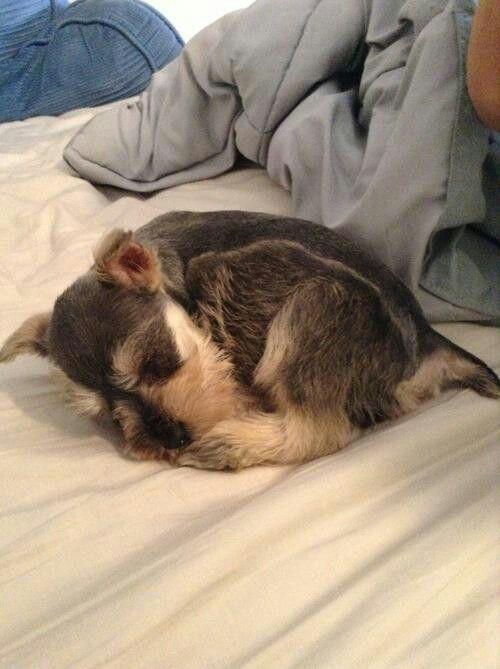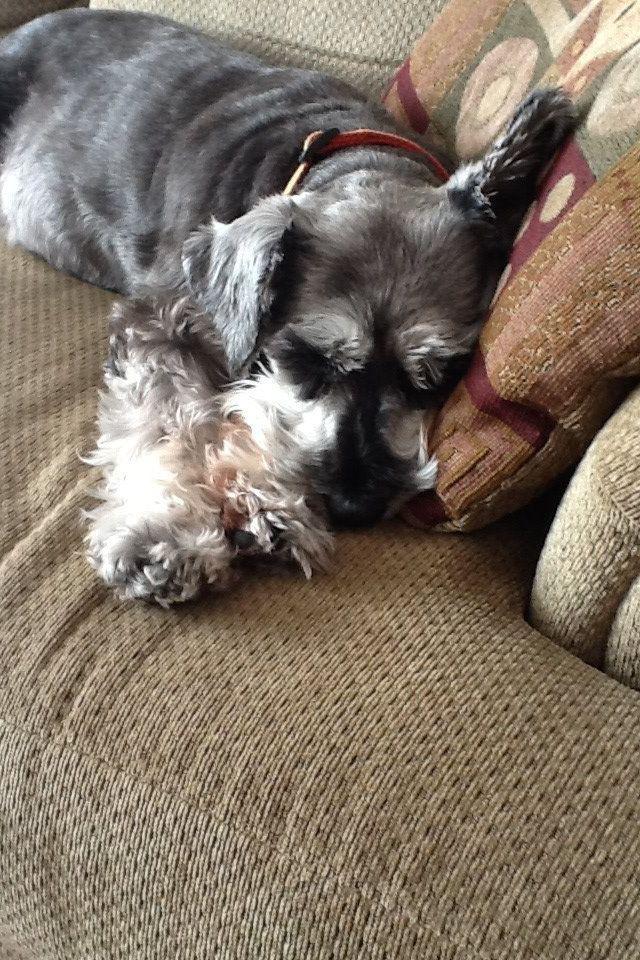The first image is the image on the left, the second image is the image on the right. Evaluate the accuracy of this statement regarding the images: "Each image contains one schnauzer posed on a piece of soft furniture.". Is it true? Answer yes or no. Yes. The first image is the image on the left, the second image is the image on the right. Considering the images on both sides, is "A dog is lying down on a white bed sheet in the left image." valid? Answer yes or no. Yes. 